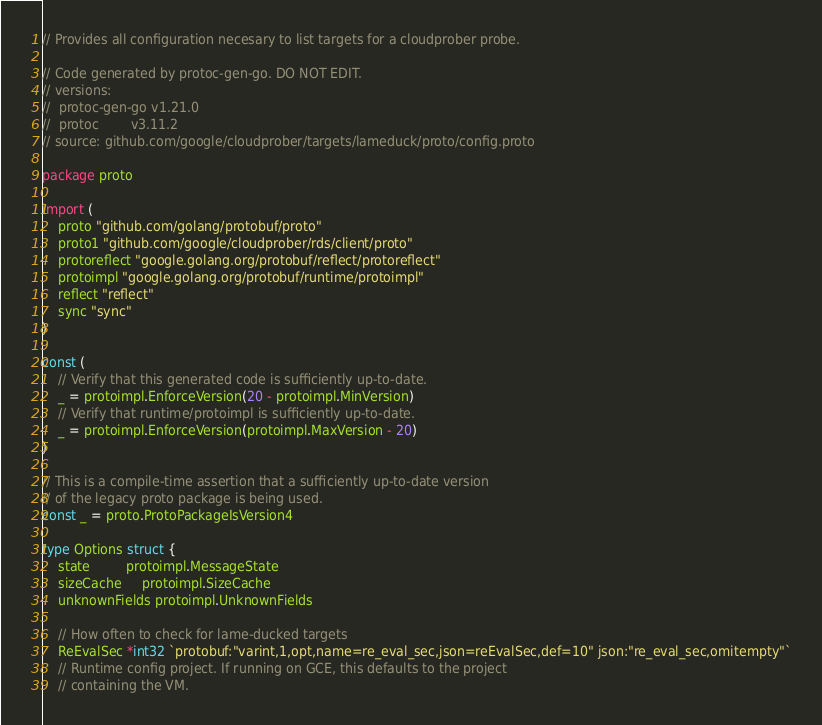<code> <loc_0><loc_0><loc_500><loc_500><_Go_>// Provides all configuration necesary to list targets for a cloudprober probe.

// Code generated by protoc-gen-go. DO NOT EDIT.
// versions:
// 	protoc-gen-go v1.21.0
// 	protoc        v3.11.2
// source: github.com/google/cloudprober/targets/lameduck/proto/config.proto

package proto

import (
	proto "github.com/golang/protobuf/proto"
	proto1 "github.com/google/cloudprober/rds/client/proto"
	protoreflect "google.golang.org/protobuf/reflect/protoreflect"
	protoimpl "google.golang.org/protobuf/runtime/protoimpl"
	reflect "reflect"
	sync "sync"
)

const (
	// Verify that this generated code is sufficiently up-to-date.
	_ = protoimpl.EnforceVersion(20 - protoimpl.MinVersion)
	// Verify that runtime/protoimpl is sufficiently up-to-date.
	_ = protoimpl.EnforceVersion(protoimpl.MaxVersion - 20)
)

// This is a compile-time assertion that a sufficiently up-to-date version
// of the legacy proto package is being used.
const _ = proto.ProtoPackageIsVersion4

type Options struct {
	state         protoimpl.MessageState
	sizeCache     protoimpl.SizeCache
	unknownFields protoimpl.UnknownFields

	// How often to check for lame-ducked targets
	ReEvalSec *int32 `protobuf:"varint,1,opt,name=re_eval_sec,json=reEvalSec,def=10" json:"re_eval_sec,omitempty"`
	// Runtime config project. If running on GCE, this defaults to the project
	// containing the VM.</code> 